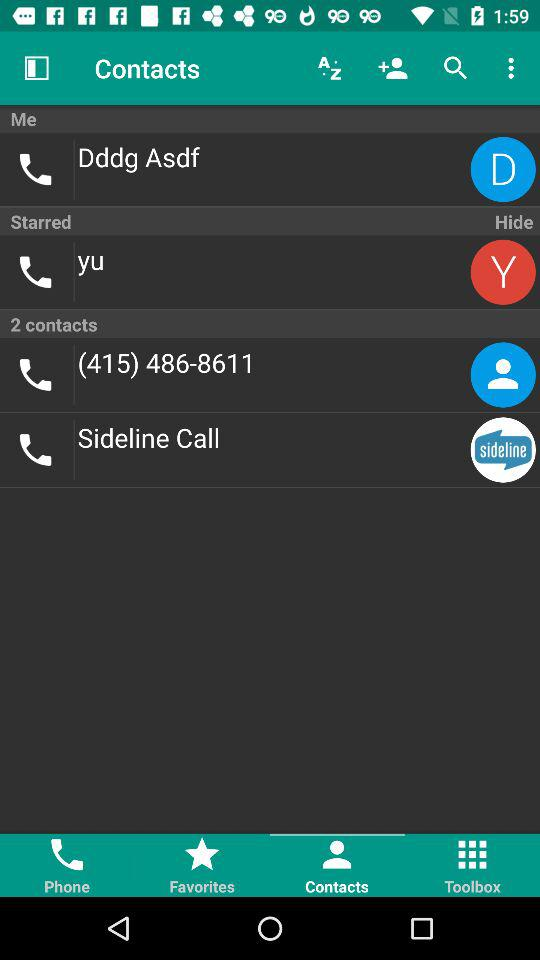What is the contact number? The contact number is (415) 486-8611. 